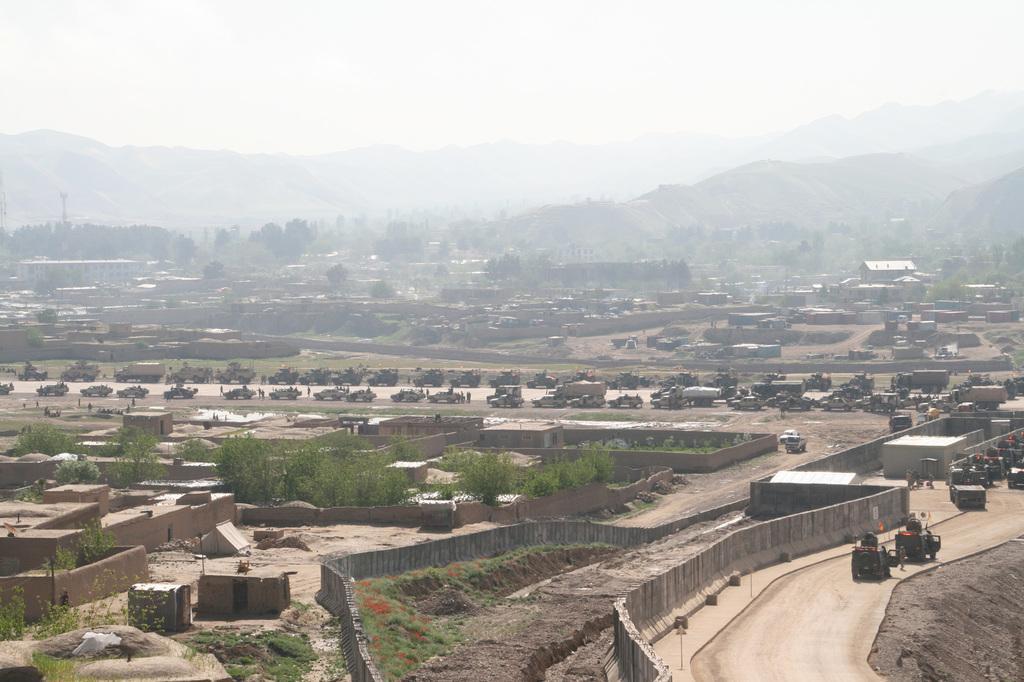Please provide a concise description of this image. In the image there are many buildings, walls, trees and there's grass on the ground. And also there are roads with vehicles. In the background there are hills. At the top of the image there is sky. 